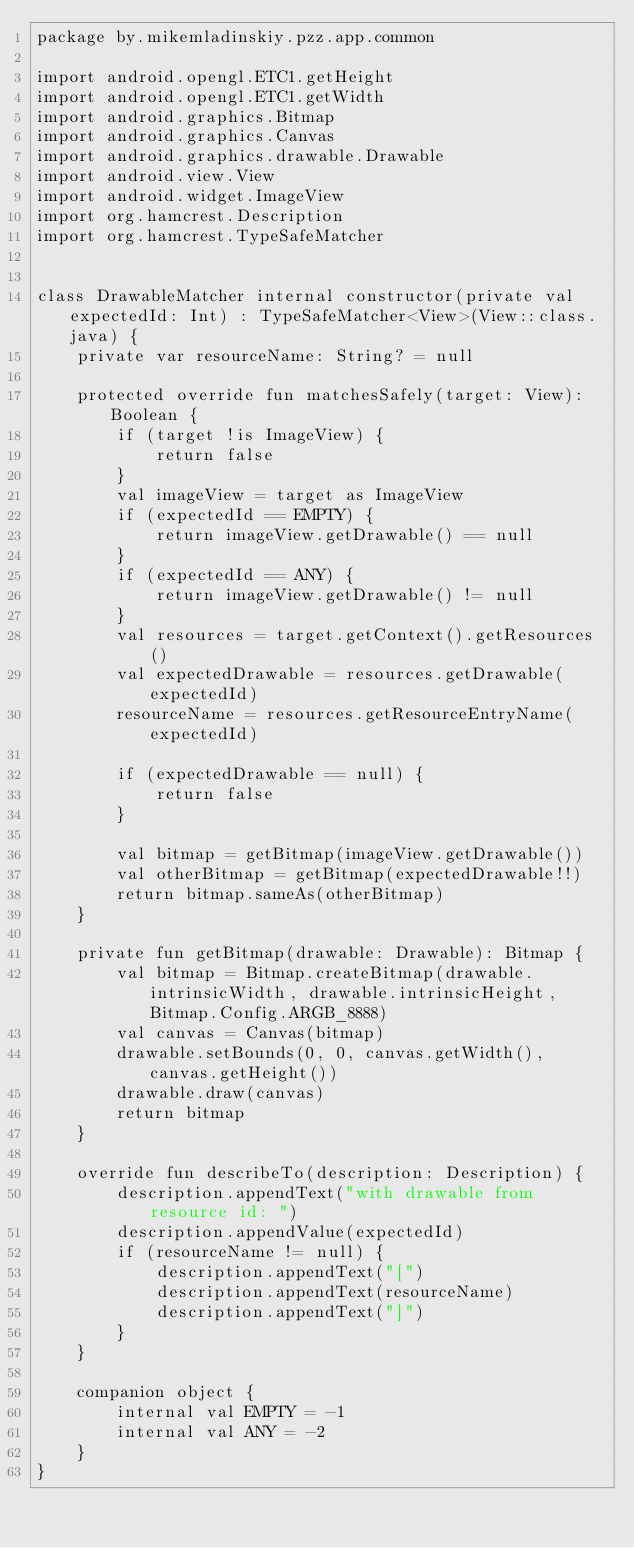<code> <loc_0><loc_0><loc_500><loc_500><_Kotlin_>package by.mikemladinskiy.pzz.app.common

import android.opengl.ETC1.getHeight
import android.opengl.ETC1.getWidth
import android.graphics.Bitmap
import android.graphics.Canvas
import android.graphics.drawable.Drawable
import android.view.View
import android.widget.ImageView
import org.hamcrest.Description
import org.hamcrest.TypeSafeMatcher


class DrawableMatcher internal constructor(private val expectedId: Int) : TypeSafeMatcher<View>(View::class.java) {
    private var resourceName: String? = null

    protected override fun matchesSafely(target: View): Boolean {
        if (target !is ImageView) {
            return false
        }
        val imageView = target as ImageView
        if (expectedId == EMPTY) {
            return imageView.getDrawable() == null
        }
        if (expectedId == ANY) {
            return imageView.getDrawable() != null
        }
        val resources = target.getContext().getResources()
        val expectedDrawable = resources.getDrawable(expectedId)
        resourceName = resources.getResourceEntryName(expectedId)

        if (expectedDrawable == null) {
            return false
        }

        val bitmap = getBitmap(imageView.getDrawable())
        val otherBitmap = getBitmap(expectedDrawable!!)
        return bitmap.sameAs(otherBitmap)
    }

    private fun getBitmap(drawable: Drawable): Bitmap {
        val bitmap = Bitmap.createBitmap(drawable.intrinsicWidth, drawable.intrinsicHeight, Bitmap.Config.ARGB_8888)
        val canvas = Canvas(bitmap)
        drawable.setBounds(0, 0, canvas.getWidth(), canvas.getHeight())
        drawable.draw(canvas)
        return bitmap
    }

    override fun describeTo(description: Description) {
        description.appendText("with drawable from resource id: ")
        description.appendValue(expectedId)
        if (resourceName != null) {
            description.appendText("[")
            description.appendText(resourceName)
            description.appendText("]")
        }
    }

    companion object {
        internal val EMPTY = -1
        internal val ANY = -2
    }
}</code> 